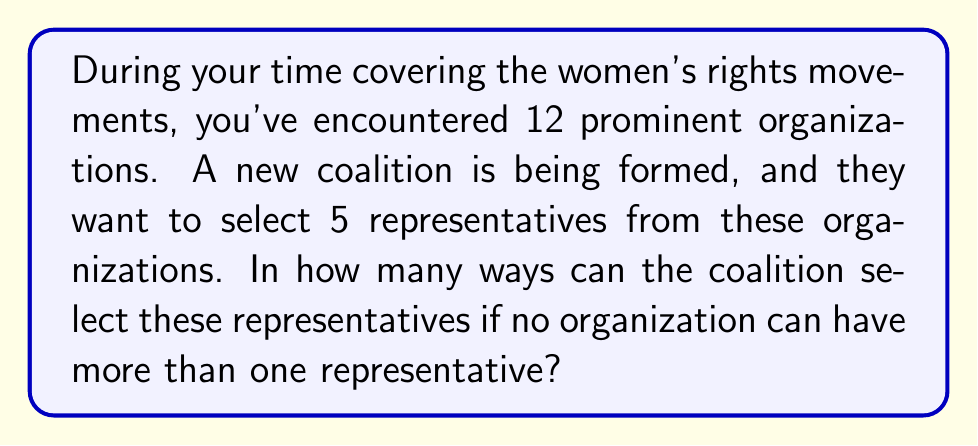Provide a solution to this math problem. To solve this problem, we need to use the combination formula. This is because:

1. The order of selection doesn't matter (it's a combination, not a permutation).
2. We're selecting 5 organizations out of 12.
3. Each organization can only be selected once.

The formula for combinations is:

$$ C(n,r) = \frac{n!}{r!(n-r)!} $$

Where:
$n$ is the total number of items to choose from (in this case, 12 organizations)
$r$ is the number of items being chosen (in this case, 5 representatives)

Plugging in our values:

$$ C(12,5) = \frac{12!}{5!(12-5)!} = \frac{12!}{5!7!} $$

Now, let's calculate this step-by-step:

1) $12! = 479,001,600$
2) $5! = 120$
3) $7! = 5,040$

Substituting these values:

$$ \frac{479,001,600}{120 \times 5,040} = \frac{479,001,600}{604,800} = 792 $$

Therefore, there are 792 possible ways to select 5 representatives from 12 organizations.
Answer: 792 